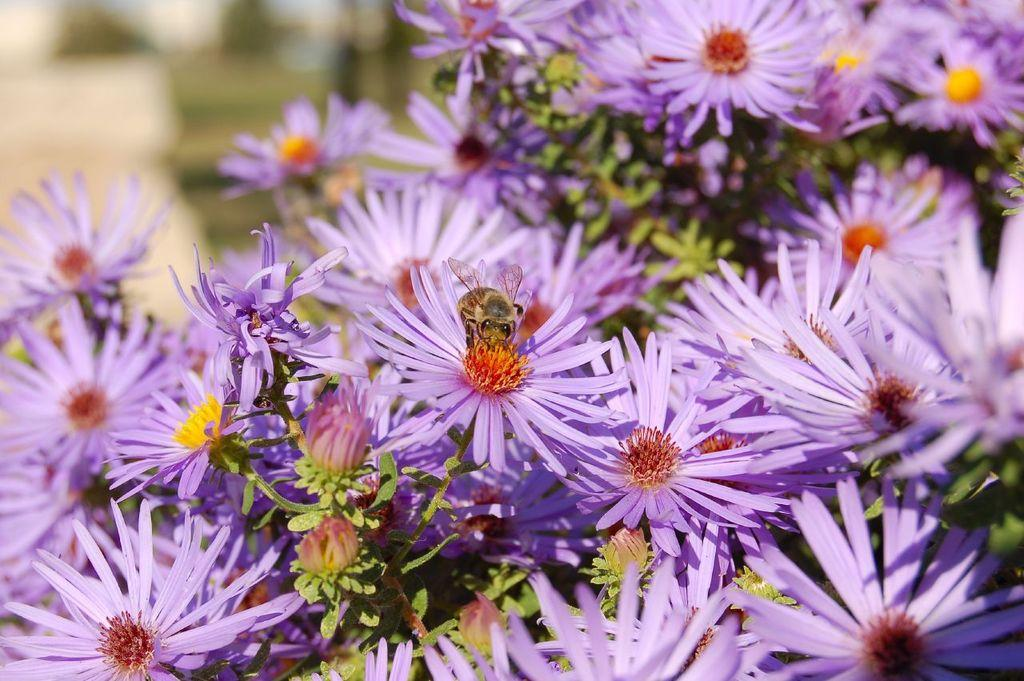What type of plants can be seen in the image? There are plants with flowers in the image. What stage of growth are some of the plants in? Some of the plants have buds. Can you describe any living organisms present on the plants? An insect is on a flower. How would you describe the background of the image? The background of the image is blurry. What idea does the balloon represent in the image? There is no balloon present in the image. 